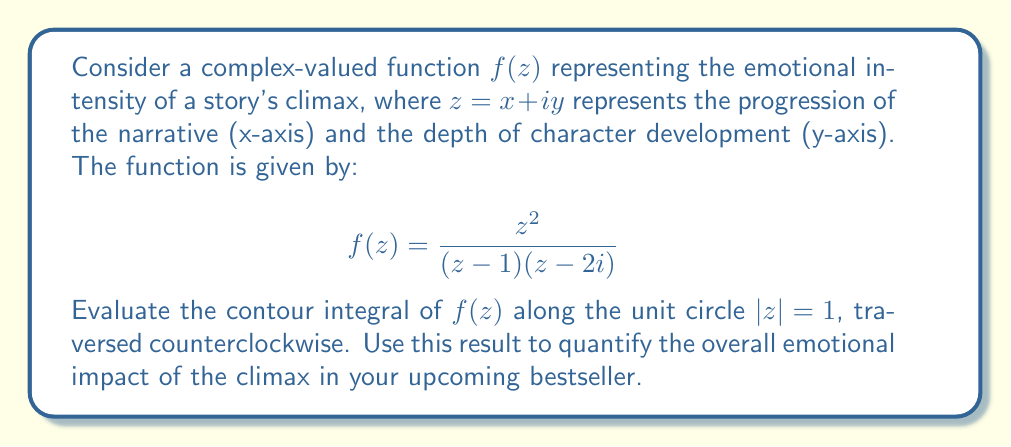Help me with this question. To evaluate this contour integral, we'll use the Residue Theorem. The steps are as follows:

1) First, we need to identify the poles of $f(z)$ inside the unit circle. The poles are at $z = 1$ and $z = 2i$. Only $z = 1$ lies inside the unit circle.

2) We calculate the residue at $z = 1$:

   $$\text{Res}(f, 1) = \lim_{z \to 1} (z-1)f(z) = \lim_{z \to 1} \frac{z^2}{z-2i} = \frac{1}{1-2i}$$

3) The Residue Theorem states that for a function $f(z)$ that is analytic except for isolated singularities inside a simple closed contour $C$:

   $$\oint_C f(z) dz = 2\pi i \sum \text{Res}(f, a_k)$$

   where $a_k$ are the poles of $f(z)$ inside $C$.

4) In our case, we have only one pole inside the unit circle, so:

   $$\oint_{|z|=1} f(z) dz = 2\pi i \cdot \frac{1}{1-2i}$$

5) To simplify this complex number, we multiply numerator and denominator by the complex conjugate of the denominator:

   $$2\pi i \cdot \frac{1}{1-2i} \cdot \frac{1+2i}{1+2i} = 2\pi i \cdot \frac{1+2i}{1+4} = 2\pi i \cdot \frac{1+2i}{5}$$

6) Separating real and imaginary parts:

   $$2\pi i \cdot (\frac{1}{5} + \frac{2i}{5}) = \frac{4\pi}{5} + \frac{2\pi i}{5}$$

The magnitude of this complex number represents the overall emotional impact of the climax:

$$\sqrt{(\frac{4\pi}{5})^2 + (\frac{2\pi}{5})^2} = \frac{2\pi\sqrt{5}}{5} \approx 2.81$$

This value quantifies the emotional intensity of your story's climax on a scale where higher values indicate more impactful climaxes.
Answer: The contour integral evaluates to $\frac{4\pi}{5} + \frac{2\pi i}{5}$, with an emotional impact magnitude of $\frac{2\pi\sqrt{5}}{5} \approx 2.81$. 